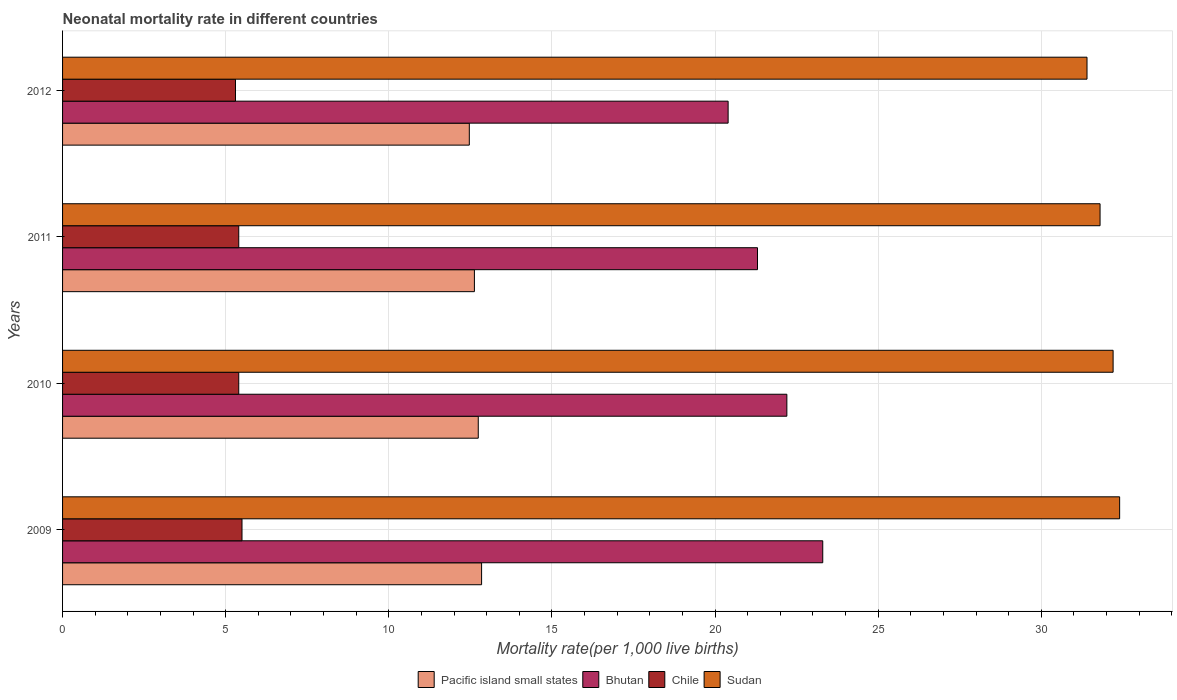How many groups of bars are there?
Your response must be concise. 4. How many bars are there on the 1st tick from the top?
Offer a terse response. 4. What is the neonatal mortality rate in Sudan in 2010?
Ensure brevity in your answer.  32.2. Across all years, what is the maximum neonatal mortality rate in Sudan?
Provide a succinct answer. 32.4. In which year was the neonatal mortality rate in Pacific island small states maximum?
Offer a terse response. 2009. In which year was the neonatal mortality rate in Sudan minimum?
Your response must be concise. 2012. What is the total neonatal mortality rate in Pacific island small states in the graph?
Offer a terse response. 50.68. What is the difference between the neonatal mortality rate in Chile in 2009 and that in 2011?
Give a very brief answer. 0.1. What is the average neonatal mortality rate in Chile per year?
Your response must be concise. 5.4. In the year 2010, what is the difference between the neonatal mortality rate in Sudan and neonatal mortality rate in Pacific island small states?
Your answer should be very brief. 19.46. In how many years, is the neonatal mortality rate in Bhutan greater than 19 ?
Keep it short and to the point. 4. What is the ratio of the neonatal mortality rate in Pacific island small states in 2010 to that in 2012?
Your answer should be compact. 1.02. Is the neonatal mortality rate in Pacific island small states in 2010 less than that in 2011?
Provide a short and direct response. No. What is the difference between the highest and the second highest neonatal mortality rate in Sudan?
Provide a short and direct response. 0.2. What is the difference between the highest and the lowest neonatal mortality rate in Chile?
Your answer should be compact. 0.2. Is the sum of the neonatal mortality rate in Sudan in 2010 and 2011 greater than the maximum neonatal mortality rate in Chile across all years?
Make the answer very short. Yes. What does the 2nd bar from the top in 2011 represents?
Offer a very short reply. Chile. What does the 2nd bar from the bottom in 2012 represents?
Your answer should be very brief. Bhutan. Is it the case that in every year, the sum of the neonatal mortality rate in Bhutan and neonatal mortality rate in Sudan is greater than the neonatal mortality rate in Chile?
Provide a succinct answer. Yes. Are all the bars in the graph horizontal?
Provide a succinct answer. Yes. Does the graph contain any zero values?
Provide a succinct answer. No. How many legend labels are there?
Your answer should be compact. 4. What is the title of the graph?
Your answer should be compact. Neonatal mortality rate in different countries. What is the label or title of the X-axis?
Your answer should be compact. Mortality rate(per 1,0 live births). What is the label or title of the Y-axis?
Provide a succinct answer. Years. What is the Mortality rate(per 1,000 live births) of Pacific island small states in 2009?
Offer a terse response. 12.84. What is the Mortality rate(per 1,000 live births) of Bhutan in 2009?
Provide a short and direct response. 23.3. What is the Mortality rate(per 1,000 live births) in Chile in 2009?
Offer a terse response. 5.5. What is the Mortality rate(per 1,000 live births) of Sudan in 2009?
Your response must be concise. 32.4. What is the Mortality rate(per 1,000 live births) of Pacific island small states in 2010?
Your answer should be compact. 12.74. What is the Mortality rate(per 1,000 live births) of Bhutan in 2010?
Make the answer very short. 22.2. What is the Mortality rate(per 1,000 live births) of Sudan in 2010?
Make the answer very short. 32.2. What is the Mortality rate(per 1,000 live births) of Pacific island small states in 2011?
Offer a terse response. 12.62. What is the Mortality rate(per 1,000 live births) in Bhutan in 2011?
Give a very brief answer. 21.3. What is the Mortality rate(per 1,000 live births) of Chile in 2011?
Your answer should be very brief. 5.4. What is the Mortality rate(per 1,000 live births) in Sudan in 2011?
Offer a terse response. 31.8. What is the Mortality rate(per 1,000 live births) in Pacific island small states in 2012?
Your answer should be very brief. 12.47. What is the Mortality rate(per 1,000 live births) of Bhutan in 2012?
Keep it short and to the point. 20.4. What is the Mortality rate(per 1,000 live births) in Sudan in 2012?
Your response must be concise. 31.4. Across all years, what is the maximum Mortality rate(per 1,000 live births) of Pacific island small states?
Ensure brevity in your answer.  12.84. Across all years, what is the maximum Mortality rate(per 1,000 live births) in Bhutan?
Give a very brief answer. 23.3. Across all years, what is the maximum Mortality rate(per 1,000 live births) of Sudan?
Provide a short and direct response. 32.4. Across all years, what is the minimum Mortality rate(per 1,000 live births) of Pacific island small states?
Offer a terse response. 12.47. Across all years, what is the minimum Mortality rate(per 1,000 live births) in Bhutan?
Your answer should be very brief. 20.4. Across all years, what is the minimum Mortality rate(per 1,000 live births) in Sudan?
Ensure brevity in your answer.  31.4. What is the total Mortality rate(per 1,000 live births) of Pacific island small states in the graph?
Ensure brevity in your answer.  50.68. What is the total Mortality rate(per 1,000 live births) of Bhutan in the graph?
Your answer should be very brief. 87.2. What is the total Mortality rate(per 1,000 live births) in Chile in the graph?
Keep it short and to the point. 21.6. What is the total Mortality rate(per 1,000 live births) of Sudan in the graph?
Offer a very short reply. 127.8. What is the difference between the Mortality rate(per 1,000 live births) of Pacific island small states in 2009 and that in 2010?
Your answer should be very brief. 0.1. What is the difference between the Mortality rate(per 1,000 live births) in Chile in 2009 and that in 2010?
Keep it short and to the point. 0.1. What is the difference between the Mortality rate(per 1,000 live births) in Pacific island small states in 2009 and that in 2011?
Provide a short and direct response. 0.22. What is the difference between the Mortality rate(per 1,000 live births) of Pacific island small states in 2009 and that in 2012?
Offer a terse response. 0.38. What is the difference between the Mortality rate(per 1,000 live births) in Bhutan in 2009 and that in 2012?
Your response must be concise. 2.9. What is the difference between the Mortality rate(per 1,000 live births) of Pacific island small states in 2010 and that in 2011?
Offer a terse response. 0.12. What is the difference between the Mortality rate(per 1,000 live births) in Chile in 2010 and that in 2011?
Give a very brief answer. 0. What is the difference between the Mortality rate(per 1,000 live births) in Sudan in 2010 and that in 2011?
Keep it short and to the point. 0.4. What is the difference between the Mortality rate(per 1,000 live births) of Pacific island small states in 2010 and that in 2012?
Ensure brevity in your answer.  0.27. What is the difference between the Mortality rate(per 1,000 live births) in Chile in 2010 and that in 2012?
Your answer should be very brief. 0.1. What is the difference between the Mortality rate(per 1,000 live births) in Pacific island small states in 2011 and that in 2012?
Keep it short and to the point. 0.16. What is the difference between the Mortality rate(per 1,000 live births) of Sudan in 2011 and that in 2012?
Your answer should be very brief. 0.4. What is the difference between the Mortality rate(per 1,000 live births) of Pacific island small states in 2009 and the Mortality rate(per 1,000 live births) of Bhutan in 2010?
Ensure brevity in your answer.  -9.36. What is the difference between the Mortality rate(per 1,000 live births) in Pacific island small states in 2009 and the Mortality rate(per 1,000 live births) in Chile in 2010?
Keep it short and to the point. 7.44. What is the difference between the Mortality rate(per 1,000 live births) in Pacific island small states in 2009 and the Mortality rate(per 1,000 live births) in Sudan in 2010?
Offer a very short reply. -19.36. What is the difference between the Mortality rate(per 1,000 live births) of Chile in 2009 and the Mortality rate(per 1,000 live births) of Sudan in 2010?
Make the answer very short. -26.7. What is the difference between the Mortality rate(per 1,000 live births) in Pacific island small states in 2009 and the Mortality rate(per 1,000 live births) in Bhutan in 2011?
Keep it short and to the point. -8.46. What is the difference between the Mortality rate(per 1,000 live births) in Pacific island small states in 2009 and the Mortality rate(per 1,000 live births) in Chile in 2011?
Offer a very short reply. 7.44. What is the difference between the Mortality rate(per 1,000 live births) in Pacific island small states in 2009 and the Mortality rate(per 1,000 live births) in Sudan in 2011?
Provide a succinct answer. -18.96. What is the difference between the Mortality rate(per 1,000 live births) in Bhutan in 2009 and the Mortality rate(per 1,000 live births) in Sudan in 2011?
Your answer should be very brief. -8.5. What is the difference between the Mortality rate(per 1,000 live births) of Chile in 2009 and the Mortality rate(per 1,000 live births) of Sudan in 2011?
Keep it short and to the point. -26.3. What is the difference between the Mortality rate(per 1,000 live births) in Pacific island small states in 2009 and the Mortality rate(per 1,000 live births) in Bhutan in 2012?
Offer a terse response. -7.56. What is the difference between the Mortality rate(per 1,000 live births) of Pacific island small states in 2009 and the Mortality rate(per 1,000 live births) of Chile in 2012?
Your answer should be compact. 7.54. What is the difference between the Mortality rate(per 1,000 live births) of Pacific island small states in 2009 and the Mortality rate(per 1,000 live births) of Sudan in 2012?
Your response must be concise. -18.56. What is the difference between the Mortality rate(per 1,000 live births) of Bhutan in 2009 and the Mortality rate(per 1,000 live births) of Chile in 2012?
Keep it short and to the point. 18. What is the difference between the Mortality rate(per 1,000 live births) of Chile in 2009 and the Mortality rate(per 1,000 live births) of Sudan in 2012?
Ensure brevity in your answer.  -25.9. What is the difference between the Mortality rate(per 1,000 live births) in Pacific island small states in 2010 and the Mortality rate(per 1,000 live births) in Bhutan in 2011?
Make the answer very short. -8.56. What is the difference between the Mortality rate(per 1,000 live births) of Pacific island small states in 2010 and the Mortality rate(per 1,000 live births) of Chile in 2011?
Provide a succinct answer. 7.34. What is the difference between the Mortality rate(per 1,000 live births) in Pacific island small states in 2010 and the Mortality rate(per 1,000 live births) in Sudan in 2011?
Provide a succinct answer. -19.06. What is the difference between the Mortality rate(per 1,000 live births) in Bhutan in 2010 and the Mortality rate(per 1,000 live births) in Chile in 2011?
Your response must be concise. 16.8. What is the difference between the Mortality rate(per 1,000 live births) in Chile in 2010 and the Mortality rate(per 1,000 live births) in Sudan in 2011?
Your answer should be compact. -26.4. What is the difference between the Mortality rate(per 1,000 live births) of Pacific island small states in 2010 and the Mortality rate(per 1,000 live births) of Bhutan in 2012?
Your answer should be compact. -7.66. What is the difference between the Mortality rate(per 1,000 live births) in Pacific island small states in 2010 and the Mortality rate(per 1,000 live births) in Chile in 2012?
Offer a very short reply. 7.44. What is the difference between the Mortality rate(per 1,000 live births) of Pacific island small states in 2010 and the Mortality rate(per 1,000 live births) of Sudan in 2012?
Your answer should be compact. -18.66. What is the difference between the Mortality rate(per 1,000 live births) in Bhutan in 2010 and the Mortality rate(per 1,000 live births) in Sudan in 2012?
Provide a short and direct response. -9.2. What is the difference between the Mortality rate(per 1,000 live births) of Chile in 2010 and the Mortality rate(per 1,000 live births) of Sudan in 2012?
Provide a succinct answer. -26. What is the difference between the Mortality rate(per 1,000 live births) of Pacific island small states in 2011 and the Mortality rate(per 1,000 live births) of Bhutan in 2012?
Offer a very short reply. -7.78. What is the difference between the Mortality rate(per 1,000 live births) in Pacific island small states in 2011 and the Mortality rate(per 1,000 live births) in Chile in 2012?
Provide a short and direct response. 7.32. What is the difference between the Mortality rate(per 1,000 live births) of Pacific island small states in 2011 and the Mortality rate(per 1,000 live births) of Sudan in 2012?
Ensure brevity in your answer.  -18.78. What is the difference between the Mortality rate(per 1,000 live births) in Bhutan in 2011 and the Mortality rate(per 1,000 live births) in Sudan in 2012?
Offer a terse response. -10.1. What is the difference between the Mortality rate(per 1,000 live births) of Chile in 2011 and the Mortality rate(per 1,000 live births) of Sudan in 2012?
Give a very brief answer. -26. What is the average Mortality rate(per 1,000 live births) in Pacific island small states per year?
Offer a very short reply. 12.67. What is the average Mortality rate(per 1,000 live births) in Bhutan per year?
Your response must be concise. 21.8. What is the average Mortality rate(per 1,000 live births) in Sudan per year?
Ensure brevity in your answer.  31.95. In the year 2009, what is the difference between the Mortality rate(per 1,000 live births) of Pacific island small states and Mortality rate(per 1,000 live births) of Bhutan?
Make the answer very short. -10.46. In the year 2009, what is the difference between the Mortality rate(per 1,000 live births) of Pacific island small states and Mortality rate(per 1,000 live births) of Chile?
Your answer should be very brief. 7.34. In the year 2009, what is the difference between the Mortality rate(per 1,000 live births) in Pacific island small states and Mortality rate(per 1,000 live births) in Sudan?
Your answer should be very brief. -19.56. In the year 2009, what is the difference between the Mortality rate(per 1,000 live births) of Chile and Mortality rate(per 1,000 live births) of Sudan?
Your response must be concise. -26.9. In the year 2010, what is the difference between the Mortality rate(per 1,000 live births) in Pacific island small states and Mortality rate(per 1,000 live births) in Bhutan?
Offer a terse response. -9.46. In the year 2010, what is the difference between the Mortality rate(per 1,000 live births) of Pacific island small states and Mortality rate(per 1,000 live births) of Chile?
Ensure brevity in your answer.  7.34. In the year 2010, what is the difference between the Mortality rate(per 1,000 live births) in Pacific island small states and Mortality rate(per 1,000 live births) in Sudan?
Ensure brevity in your answer.  -19.46. In the year 2010, what is the difference between the Mortality rate(per 1,000 live births) of Bhutan and Mortality rate(per 1,000 live births) of Sudan?
Give a very brief answer. -10. In the year 2010, what is the difference between the Mortality rate(per 1,000 live births) of Chile and Mortality rate(per 1,000 live births) of Sudan?
Ensure brevity in your answer.  -26.8. In the year 2011, what is the difference between the Mortality rate(per 1,000 live births) in Pacific island small states and Mortality rate(per 1,000 live births) in Bhutan?
Your answer should be compact. -8.68. In the year 2011, what is the difference between the Mortality rate(per 1,000 live births) in Pacific island small states and Mortality rate(per 1,000 live births) in Chile?
Keep it short and to the point. 7.22. In the year 2011, what is the difference between the Mortality rate(per 1,000 live births) of Pacific island small states and Mortality rate(per 1,000 live births) of Sudan?
Your response must be concise. -19.18. In the year 2011, what is the difference between the Mortality rate(per 1,000 live births) in Bhutan and Mortality rate(per 1,000 live births) in Sudan?
Your answer should be compact. -10.5. In the year 2011, what is the difference between the Mortality rate(per 1,000 live births) of Chile and Mortality rate(per 1,000 live births) of Sudan?
Give a very brief answer. -26.4. In the year 2012, what is the difference between the Mortality rate(per 1,000 live births) of Pacific island small states and Mortality rate(per 1,000 live births) of Bhutan?
Ensure brevity in your answer.  -7.93. In the year 2012, what is the difference between the Mortality rate(per 1,000 live births) of Pacific island small states and Mortality rate(per 1,000 live births) of Chile?
Your response must be concise. 7.17. In the year 2012, what is the difference between the Mortality rate(per 1,000 live births) in Pacific island small states and Mortality rate(per 1,000 live births) in Sudan?
Make the answer very short. -18.93. In the year 2012, what is the difference between the Mortality rate(per 1,000 live births) of Chile and Mortality rate(per 1,000 live births) of Sudan?
Make the answer very short. -26.1. What is the ratio of the Mortality rate(per 1,000 live births) in Pacific island small states in 2009 to that in 2010?
Offer a terse response. 1.01. What is the ratio of the Mortality rate(per 1,000 live births) in Bhutan in 2009 to that in 2010?
Your answer should be very brief. 1.05. What is the ratio of the Mortality rate(per 1,000 live births) of Chile in 2009 to that in 2010?
Offer a terse response. 1.02. What is the ratio of the Mortality rate(per 1,000 live births) of Sudan in 2009 to that in 2010?
Keep it short and to the point. 1.01. What is the ratio of the Mortality rate(per 1,000 live births) in Pacific island small states in 2009 to that in 2011?
Keep it short and to the point. 1.02. What is the ratio of the Mortality rate(per 1,000 live births) in Bhutan in 2009 to that in 2011?
Your answer should be compact. 1.09. What is the ratio of the Mortality rate(per 1,000 live births) of Chile in 2009 to that in 2011?
Ensure brevity in your answer.  1.02. What is the ratio of the Mortality rate(per 1,000 live births) of Sudan in 2009 to that in 2011?
Keep it short and to the point. 1.02. What is the ratio of the Mortality rate(per 1,000 live births) of Pacific island small states in 2009 to that in 2012?
Your answer should be compact. 1.03. What is the ratio of the Mortality rate(per 1,000 live births) in Bhutan in 2009 to that in 2012?
Provide a short and direct response. 1.14. What is the ratio of the Mortality rate(per 1,000 live births) in Chile in 2009 to that in 2012?
Provide a short and direct response. 1.04. What is the ratio of the Mortality rate(per 1,000 live births) in Sudan in 2009 to that in 2012?
Give a very brief answer. 1.03. What is the ratio of the Mortality rate(per 1,000 live births) of Pacific island small states in 2010 to that in 2011?
Offer a very short reply. 1.01. What is the ratio of the Mortality rate(per 1,000 live births) of Bhutan in 2010 to that in 2011?
Provide a succinct answer. 1.04. What is the ratio of the Mortality rate(per 1,000 live births) in Sudan in 2010 to that in 2011?
Your response must be concise. 1.01. What is the ratio of the Mortality rate(per 1,000 live births) of Pacific island small states in 2010 to that in 2012?
Offer a terse response. 1.02. What is the ratio of the Mortality rate(per 1,000 live births) in Bhutan in 2010 to that in 2012?
Offer a very short reply. 1.09. What is the ratio of the Mortality rate(per 1,000 live births) in Chile in 2010 to that in 2012?
Make the answer very short. 1.02. What is the ratio of the Mortality rate(per 1,000 live births) of Sudan in 2010 to that in 2012?
Offer a very short reply. 1.03. What is the ratio of the Mortality rate(per 1,000 live births) in Pacific island small states in 2011 to that in 2012?
Make the answer very short. 1.01. What is the ratio of the Mortality rate(per 1,000 live births) of Bhutan in 2011 to that in 2012?
Offer a terse response. 1.04. What is the ratio of the Mortality rate(per 1,000 live births) of Chile in 2011 to that in 2012?
Provide a succinct answer. 1.02. What is the ratio of the Mortality rate(per 1,000 live births) of Sudan in 2011 to that in 2012?
Make the answer very short. 1.01. What is the difference between the highest and the second highest Mortality rate(per 1,000 live births) of Pacific island small states?
Your answer should be compact. 0.1. What is the difference between the highest and the second highest Mortality rate(per 1,000 live births) in Chile?
Offer a very short reply. 0.1. What is the difference between the highest and the lowest Mortality rate(per 1,000 live births) of Pacific island small states?
Your answer should be compact. 0.38. 